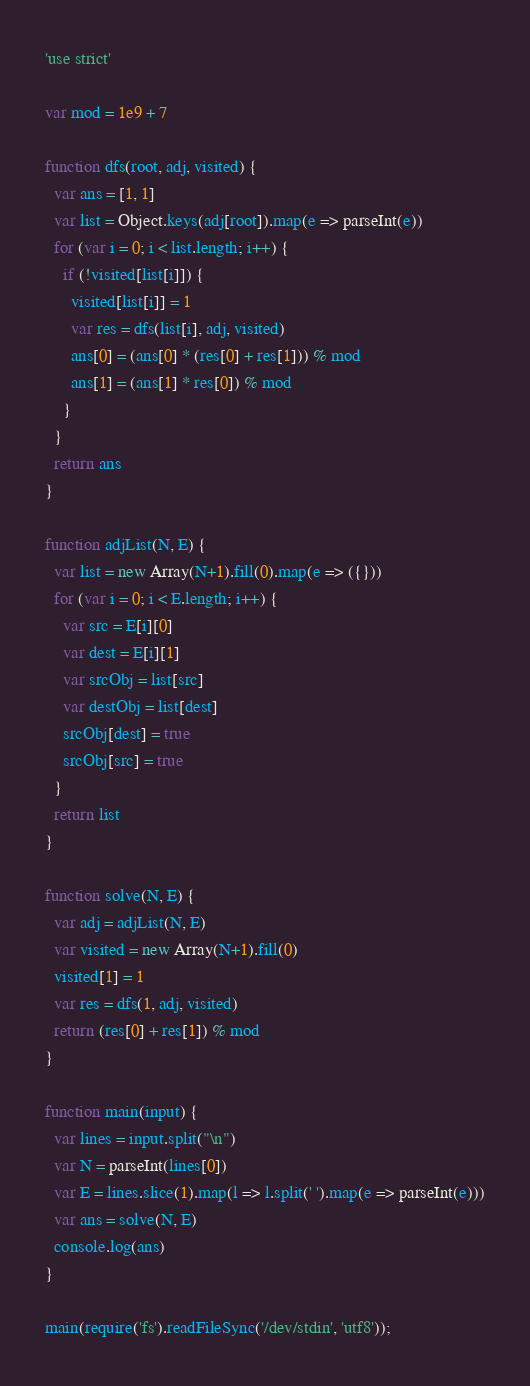Convert code to text. <code><loc_0><loc_0><loc_500><loc_500><_JavaScript_>'use strict'

var mod = 1e9 + 7

function dfs(root, adj, visited) {
  var ans = [1, 1]
  var list = Object.keys(adj[root]).map(e => parseInt(e))
  for (var i = 0; i < list.length; i++) {
    if (!visited[list[i]]) {
      visited[list[i]] = 1
      var res = dfs(list[i], adj, visited)
      ans[0] = (ans[0] * (res[0] + res[1])) % mod
      ans[1] = (ans[1] * res[0]) % mod
    }
  }
  return ans
}

function adjList(N, E) {
  var list = new Array(N+1).fill(0).map(e => ({}))
  for (var i = 0; i < E.length; i++) {
    var src = E[i][0]
    var dest = E[i][1]
    var srcObj = list[src]
    var destObj = list[dest]
    srcObj[dest] = true
    srcObj[src] = true
  }
  return list
}

function solve(N, E) {
  var adj = adjList(N, E)
  var visited = new Array(N+1).fill(0)
  visited[1] = 1
  var res = dfs(1, adj, visited)
  return (res[0] + res[1]) % mod
}

function main(input) {
  var lines = input.split("\n")
  var N = parseInt(lines[0])
  var E = lines.slice(1).map(l => l.split(' ').map(e => parseInt(e)))
  var ans = solve(N, E)
  console.log(ans)
}

main(require('fs').readFileSync('/dev/stdin', 'utf8'));
</code> 